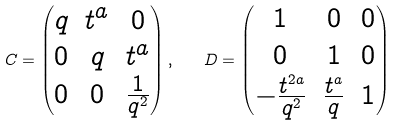<formula> <loc_0><loc_0><loc_500><loc_500>C = \begin{pmatrix} q & t ^ { a } & 0 \\ 0 & q & t ^ { a } \\ 0 & 0 & \frac { 1 } { q ^ { 2 } } \end{pmatrix} , \quad D = \begin{pmatrix} 1 & 0 & 0 \\ 0 & 1 & 0 \\ - \frac { t ^ { 2 a } } { q ^ { 2 } } & \frac { t ^ { a } } { q } & 1 \end{pmatrix}</formula> 